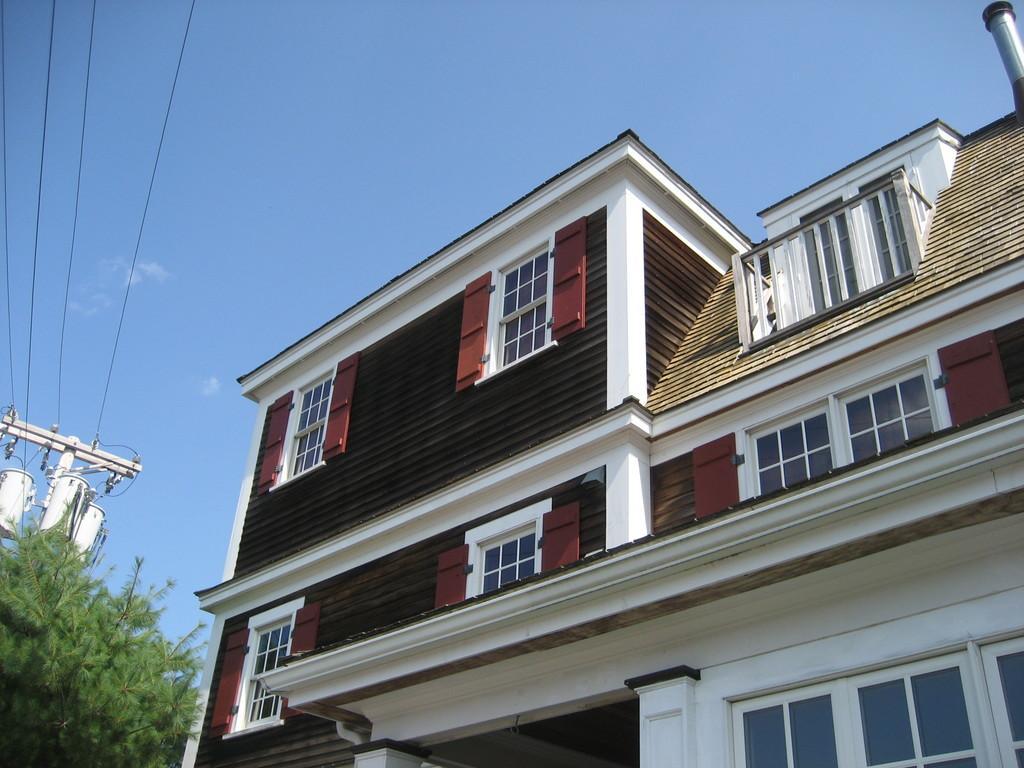Could you give a brief overview of what you see in this image? In this image we can see a building, there are some trees, windows, wires and an electric pole, in the background, we can see the sky with clouds. 